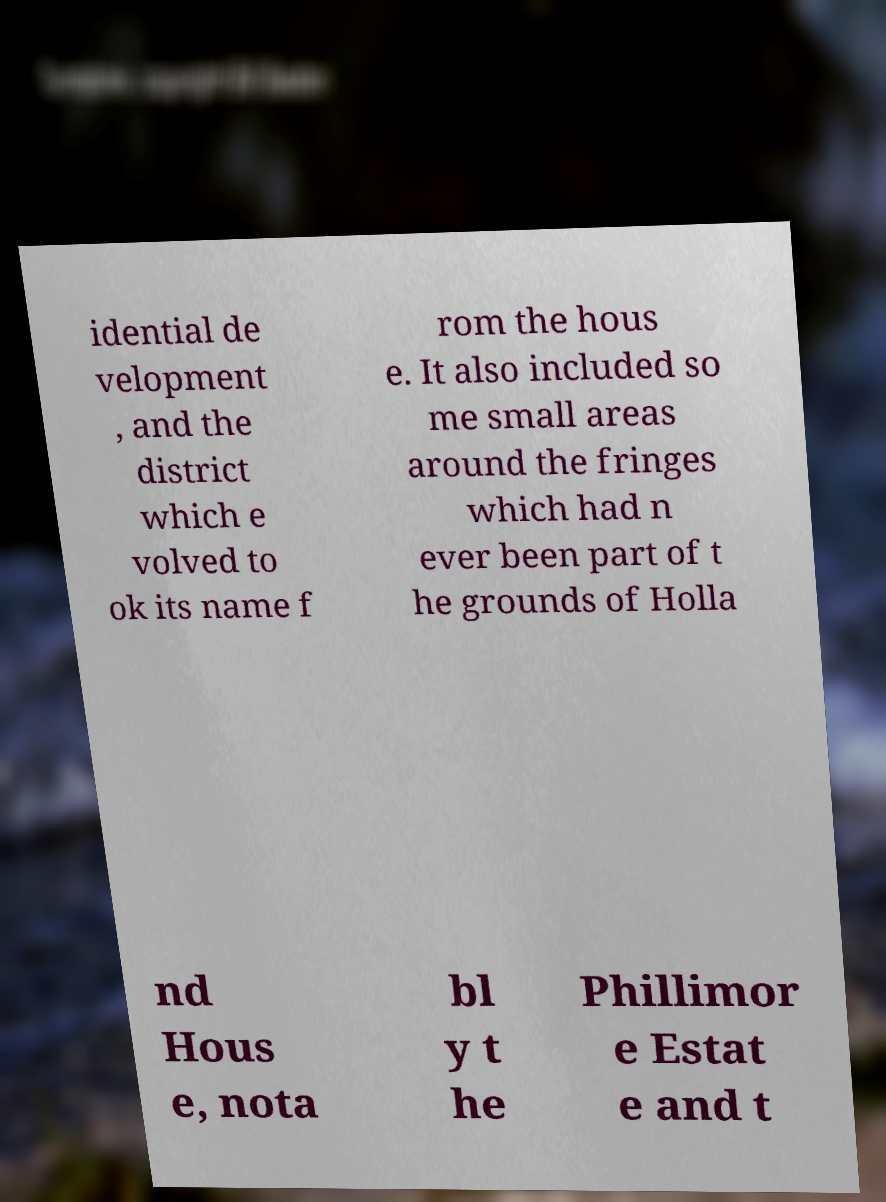There's text embedded in this image that I need extracted. Can you transcribe it verbatim? idential de velopment , and the district which e volved to ok its name f rom the hous e. It also included so me small areas around the fringes which had n ever been part of t he grounds of Holla nd Hous e, nota bl y t he Phillimor e Estat e and t 